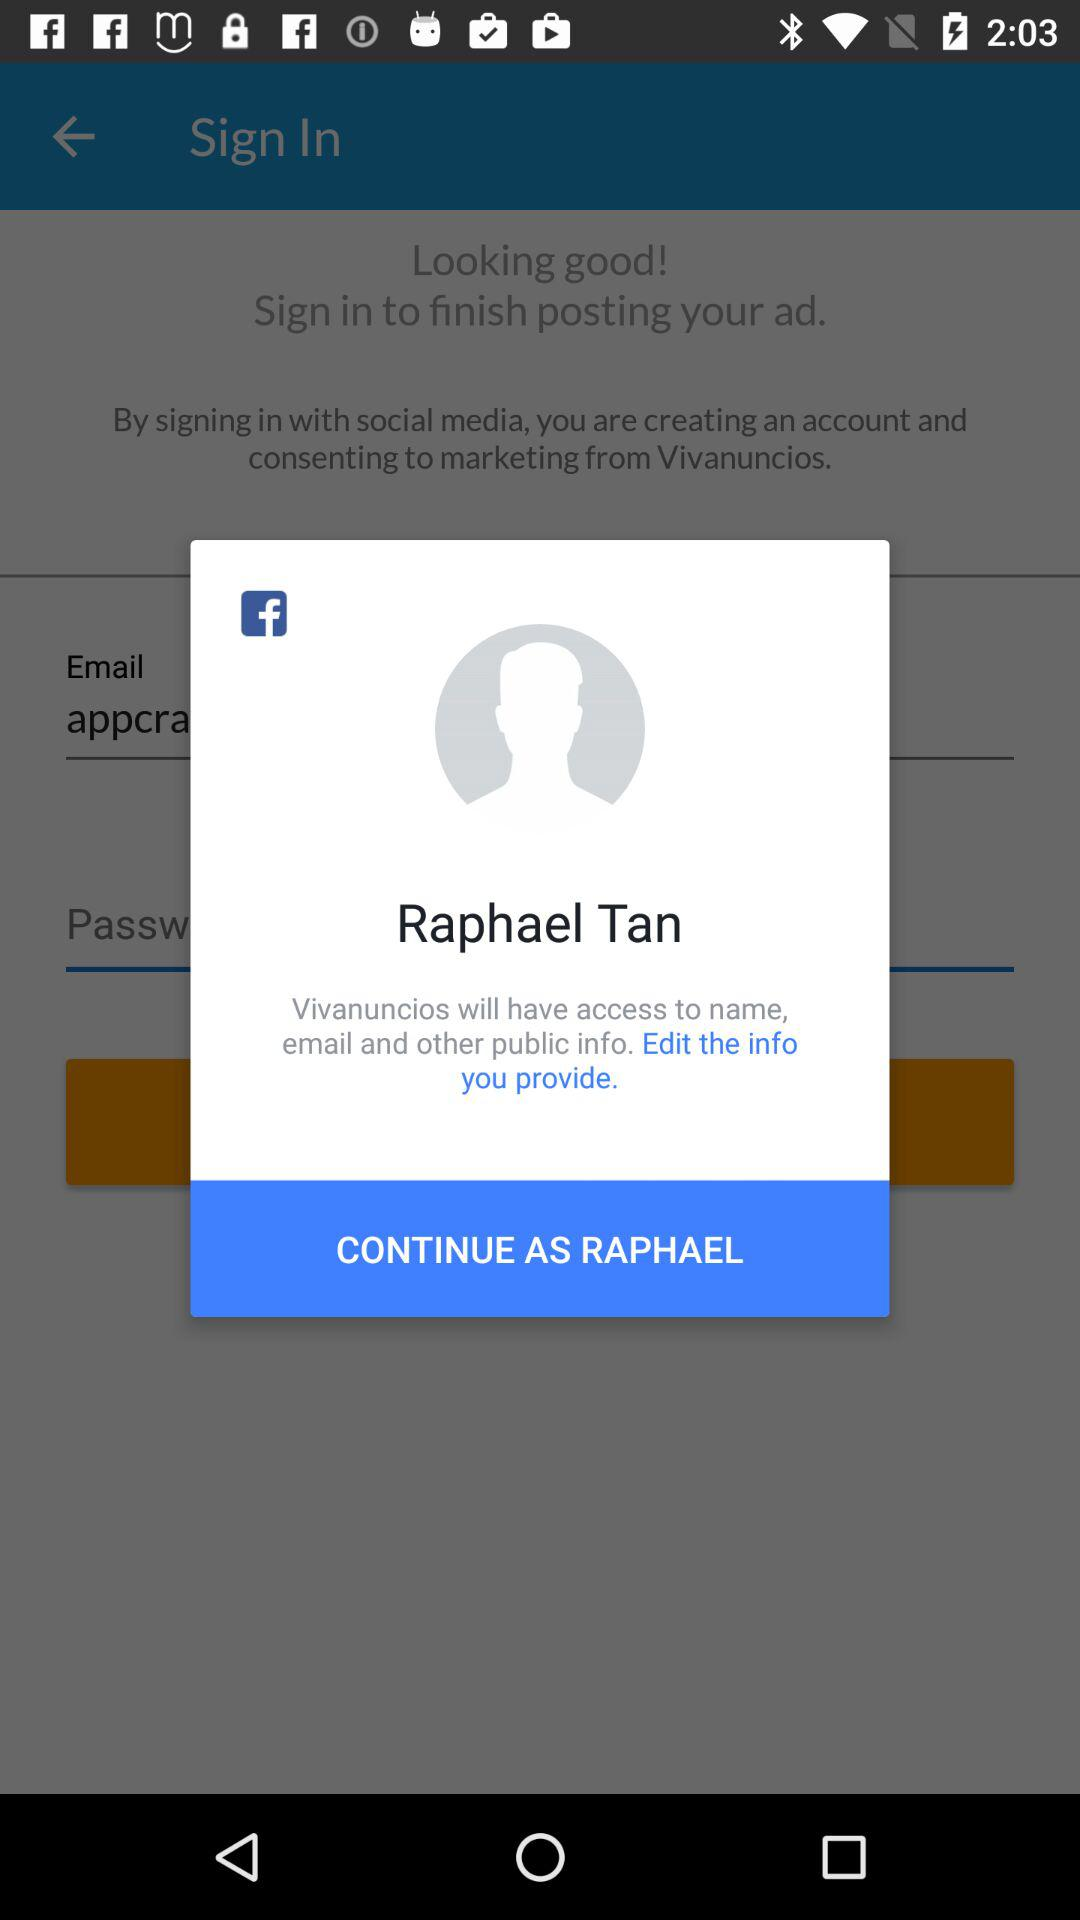What application is used for sign in? You can sign in with "Facebook". 